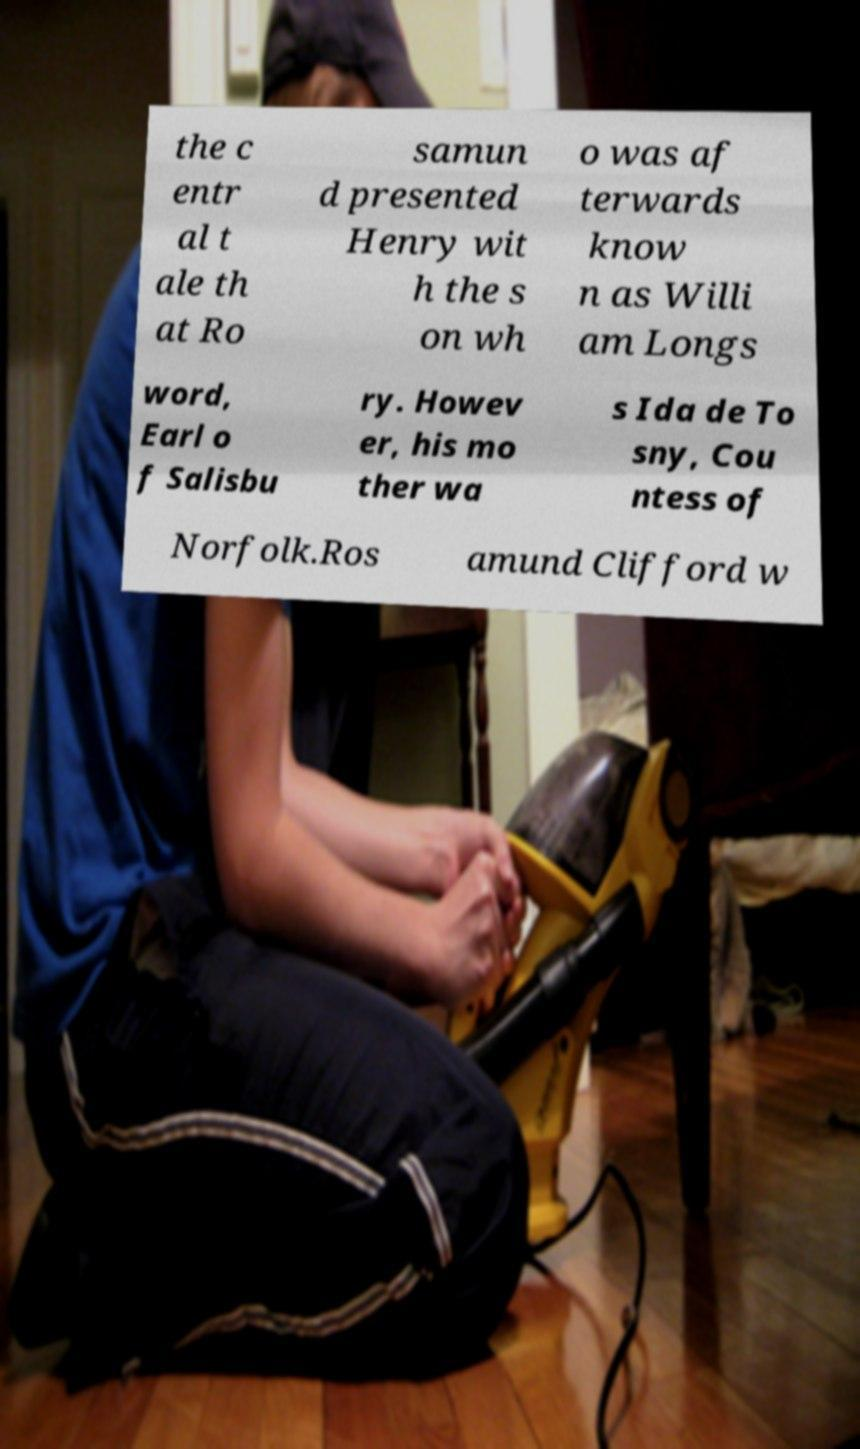I need the written content from this picture converted into text. Can you do that? the c entr al t ale th at Ro samun d presented Henry wit h the s on wh o was af terwards know n as Willi am Longs word, Earl o f Salisbu ry. Howev er, his mo ther wa s Ida de To sny, Cou ntess of Norfolk.Ros amund Clifford w 